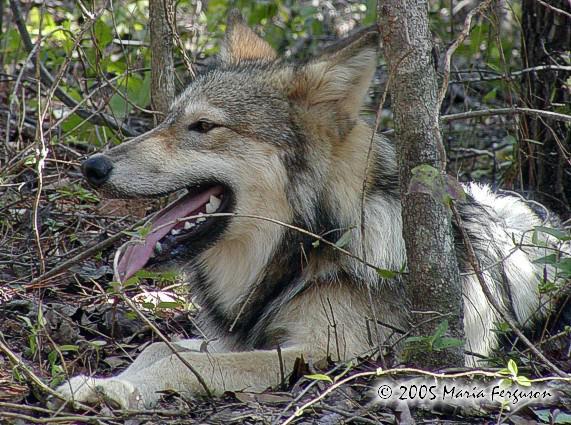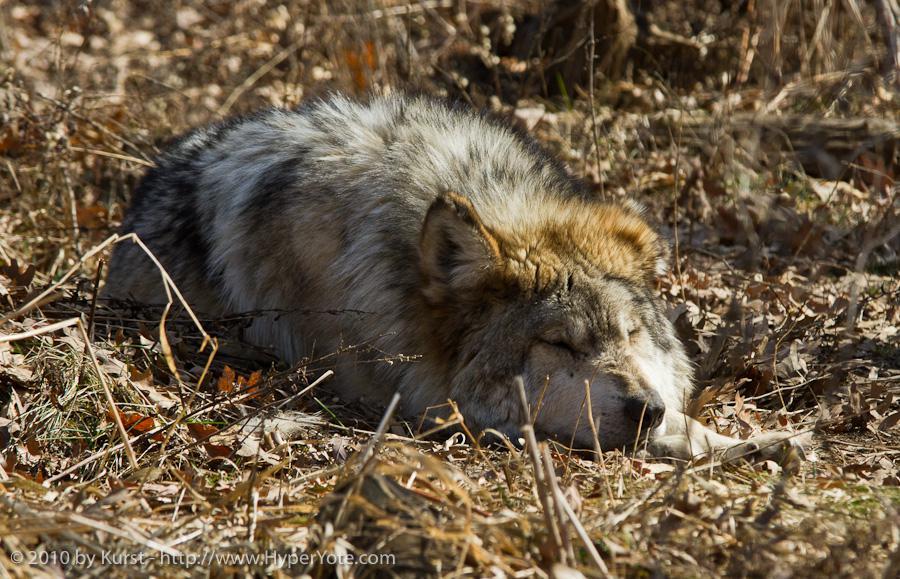The first image is the image on the left, the second image is the image on the right. For the images displayed, is the sentence "Both wolves are lying down and one is laying it's head on it's legs." factually correct? Answer yes or no. Yes. The first image is the image on the left, the second image is the image on the right. Evaluate the accuracy of this statement regarding the images: "One wolf's teeth are visible.". Is it true? Answer yes or no. Yes. 